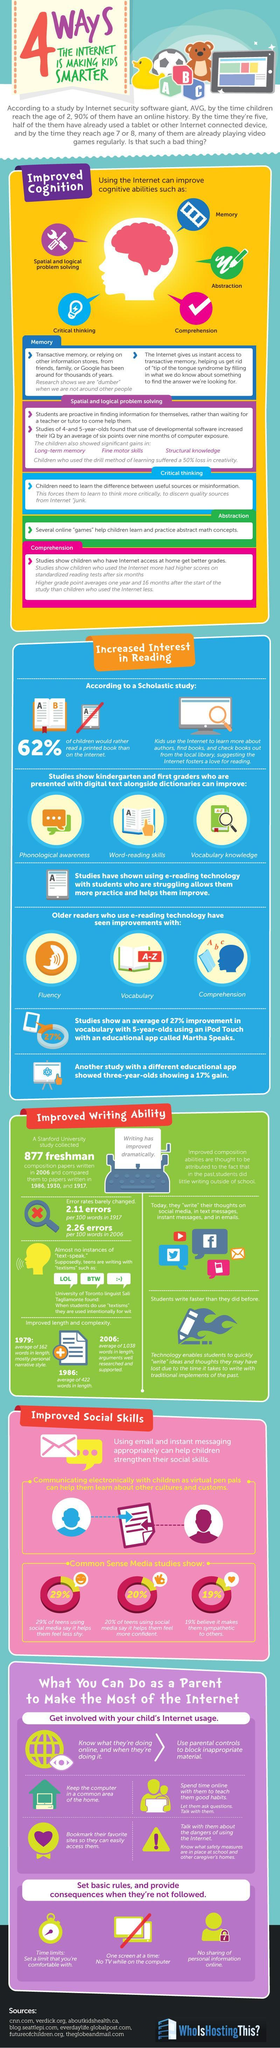Other than spatial and logical problem solving and critical thinking, what are the other cognitive skills developed using internet
Answer the question with a short phrase. memory, abstraction, comprehension What are the alphabets written on the cubes beside the duck A, B, C What improvement has older readers who use e-reading technology noticed fluency, vocabulary, comprehension what is printed on the paper of the type writer writing has improved dramatically What has been the increase in errors per 100 words from 1917 to 2006 0.15 What is the difference / increase of average words in length from 1979 to 1986 260 the 2006 composition papers were compared with which years? 1986, 1939, and 1917 